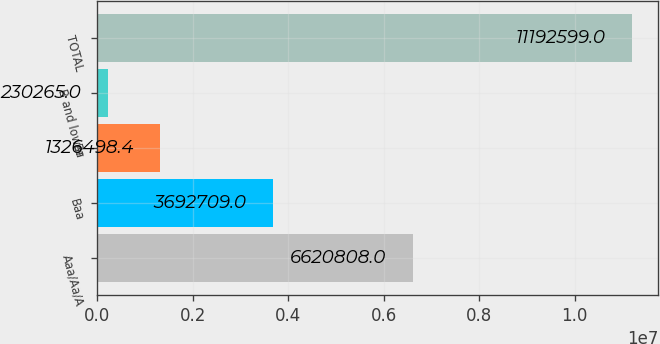<chart> <loc_0><loc_0><loc_500><loc_500><bar_chart><fcel>Aaa/Aa/A<fcel>Baa<fcel>Ba<fcel>B and lower<fcel>TOTAL<nl><fcel>6.62081e+06<fcel>3.69271e+06<fcel>1.3265e+06<fcel>230265<fcel>1.11926e+07<nl></chart> 